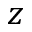<formula> <loc_0><loc_0><loc_500><loc_500>z</formula> 